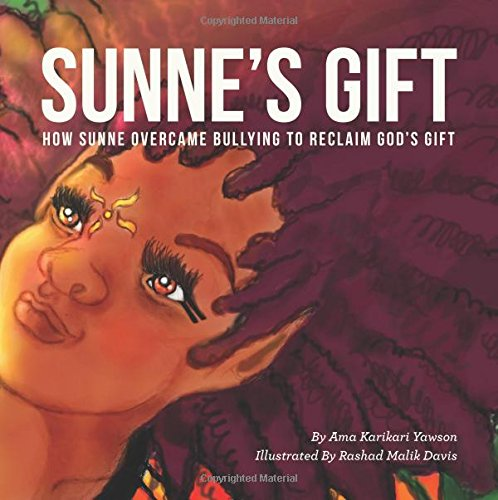What is the main theme or message of this book? The main theme of 'Sunne's Gift' is about overcoming bullying and embracing one's unique gifts, promoting self-acceptance and resilience among young readers. 